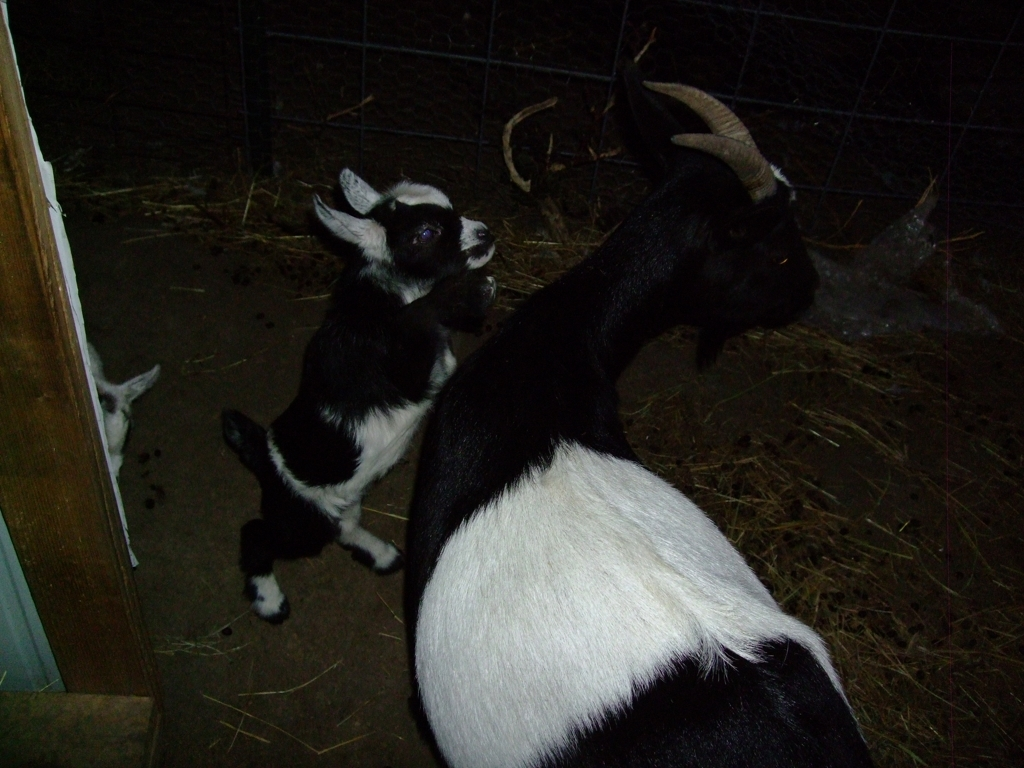What time of day does this picture seem like it was taken? Based on the low light conditions and artificial lighting coming from one side, this picture might have been taken during the evening or night time when natural light is scarce, causing the shadows and the grainy quality of the image. Is there anything in the picture that suggests a location or setting? While specific location details are not visible, the surrounding wire fence and the straw on the ground suggest that the goats are in a pen or barnyard designed for raising livestock, possibly on a farm or a similar rural setting. 